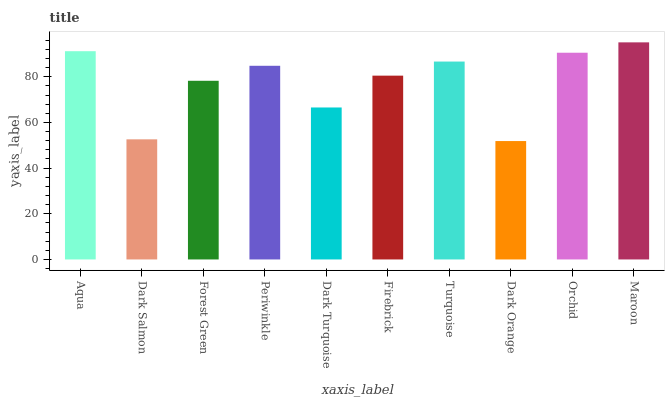Is Dark Orange the minimum?
Answer yes or no. Yes. Is Maroon the maximum?
Answer yes or no. Yes. Is Dark Salmon the minimum?
Answer yes or no. No. Is Dark Salmon the maximum?
Answer yes or no. No. Is Aqua greater than Dark Salmon?
Answer yes or no. Yes. Is Dark Salmon less than Aqua?
Answer yes or no. Yes. Is Dark Salmon greater than Aqua?
Answer yes or no. No. Is Aqua less than Dark Salmon?
Answer yes or no. No. Is Periwinkle the high median?
Answer yes or no. Yes. Is Firebrick the low median?
Answer yes or no. Yes. Is Firebrick the high median?
Answer yes or no. No. Is Dark Orange the low median?
Answer yes or no. No. 